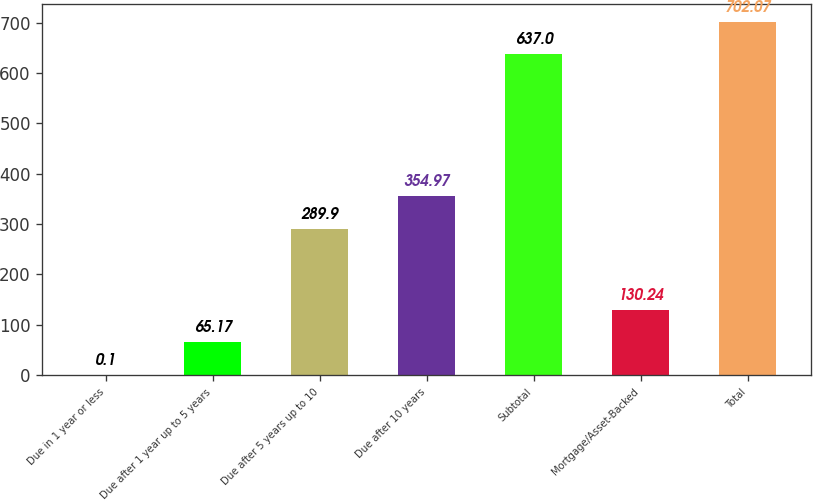Convert chart to OTSL. <chart><loc_0><loc_0><loc_500><loc_500><bar_chart><fcel>Due in 1 year or less<fcel>Due after 1 year up to 5 years<fcel>Due after 5 years up to 10<fcel>Due after 10 years<fcel>Subtotal<fcel>Mortgage/Asset-Backed<fcel>Total<nl><fcel>0.1<fcel>65.17<fcel>289.9<fcel>354.97<fcel>637<fcel>130.24<fcel>702.07<nl></chart> 